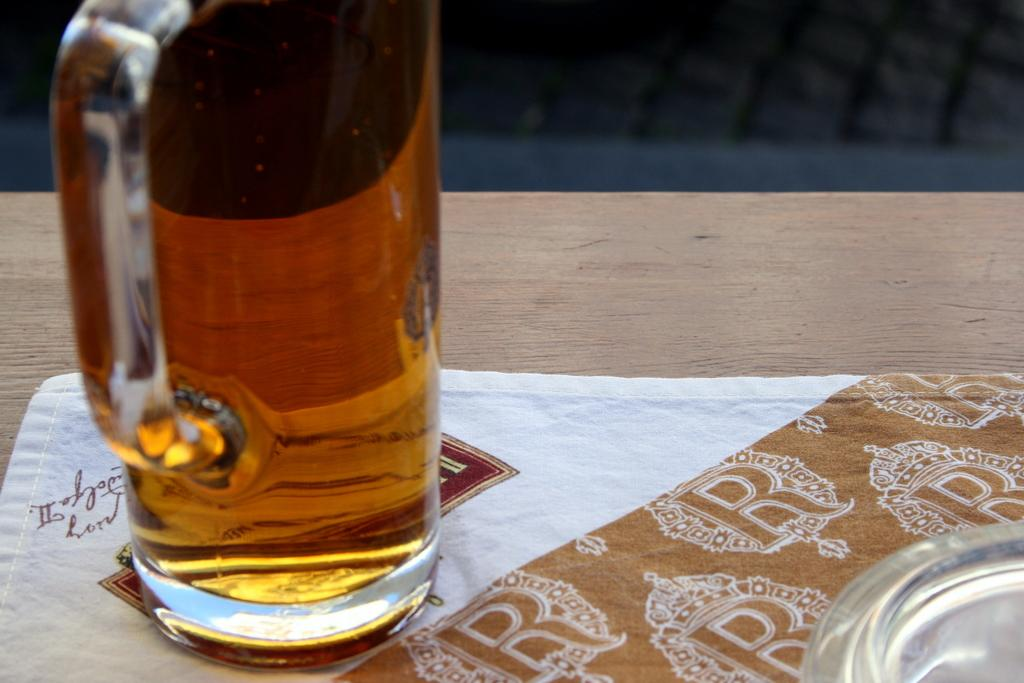What type of objects are made of glass in the image? There are glass objects in the image. What type of material is present in the image besides glass? There is cloth in the image. What is the surface made of that the glass objects and cloth are placed on? The wooden surface is present in the image. What type of cheese is visible in the image? There is no cheese present in the image. How many tanks are visible in the image? There are no tanks present in the image. 